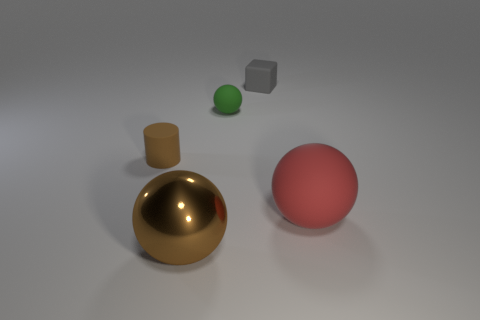Is there any other thing that is the same material as the large brown thing?
Your answer should be very brief. No. Are there any rubber spheres behind the brown matte object?
Make the answer very short. Yes. The rubber ball that is in front of the green rubber object is what color?
Provide a succinct answer. Red. There is a brown object on the right side of the object that is left of the large brown ball; what is it made of?
Make the answer very short. Metal. Are there fewer gray cubes that are right of the big red sphere than large objects left of the small green sphere?
Give a very brief answer. Yes. How many red objects are either big things or rubber cylinders?
Offer a very short reply. 1. Is the number of big red matte spheres behind the big matte sphere the same as the number of large things?
Your response must be concise. No. How many objects are small brown matte objects or things that are to the left of the red ball?
Keep it short and to the point. 4. Do the small rubber cylinder and the shiny thing have the same color?
Your response must be concise. Yes. Is there another small green sphere made of the same material as the green sphere?
Provide a short and direct response. No. 